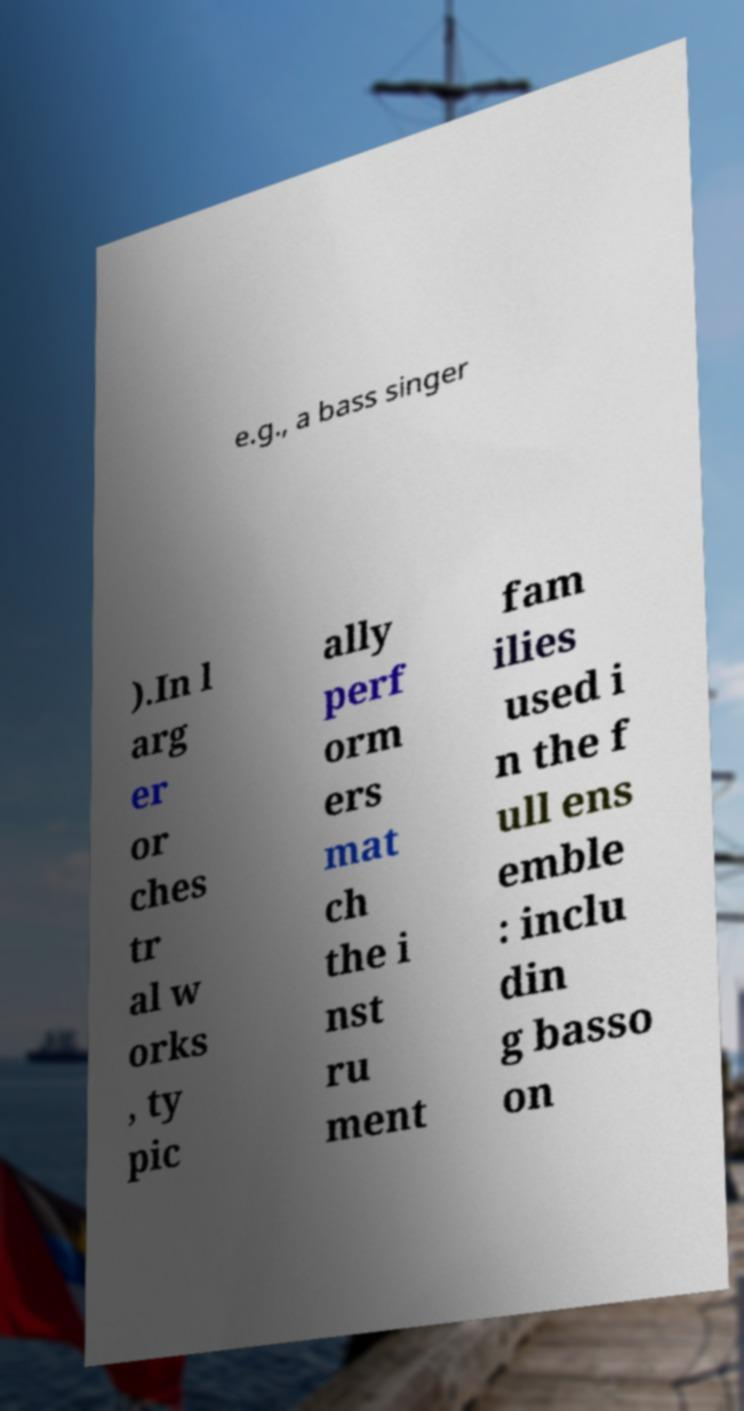What messages or text are displayed in this image? I need them in a readable, typed format. e.g., a bass singer ).In l arg er or ches tr al w orks , ty pic ally perf orm ers mat ch the i nst ru ment fam ilies used i n the f ull ens emble : inclu din g basso on 